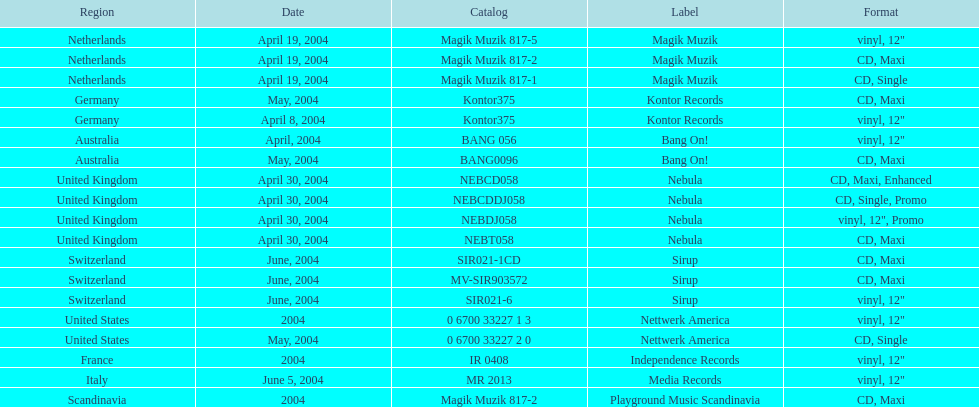What region is above australia? Germany. 